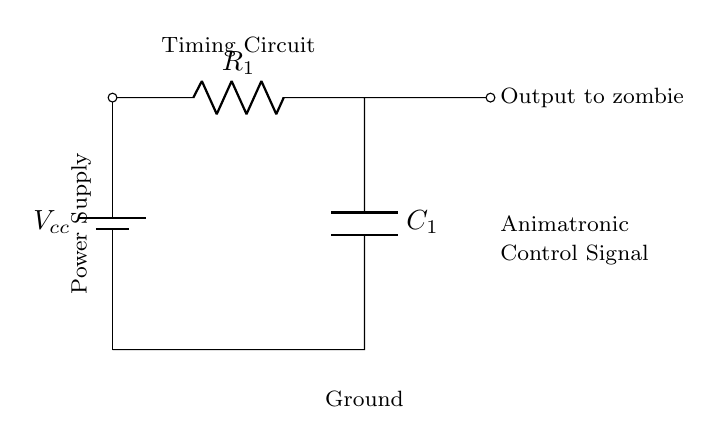What type of circuit is depicted here? This circuit is a Resistor-Capacitor (RC) timing circuit, which is characterized by a resistor and a capacitor connected in series or parallel to create a time delay. The components are labeled ‘R’ for resistor and ‘C’ for capacitor.
Answer: RC timing circuit What is the purpose of the capacitor in this circuit? The capacitor stores energy and helps to control the timing of the output signal. It charges through the resistor and discharges when needed, affecting the timing of animations for the zombies.
Answer: Timing control What value does the indicated resistor represent? The resistor is labeled as ‘R1’ in the circuit, but the specific value isn't provided in this context. It generally affects how quickly the capacitor charges and discharges.
Answer: R1 What does the battery supply in this circuit? The battery supplies voltage to the circuit, which is essential for the operation of the timing mechanism and for controlling the output signals to the animatronics.
Answer: Voltage How does the timing affect animatronic movement? The timing control provided by the RC circuit determines the delay before the animatronic reacts, creating a more realistic and thrilling experience in the zombie movie setting.
Answer: Movement timing What happens when the capacitor is fully charged? When the capacitor is fully charged, it reaches the supply voltage, and the output signal will reflect this state, halting changes in the animatronic's movement temporarily until the capacitor discharges.
Answer: Signal stabilization 